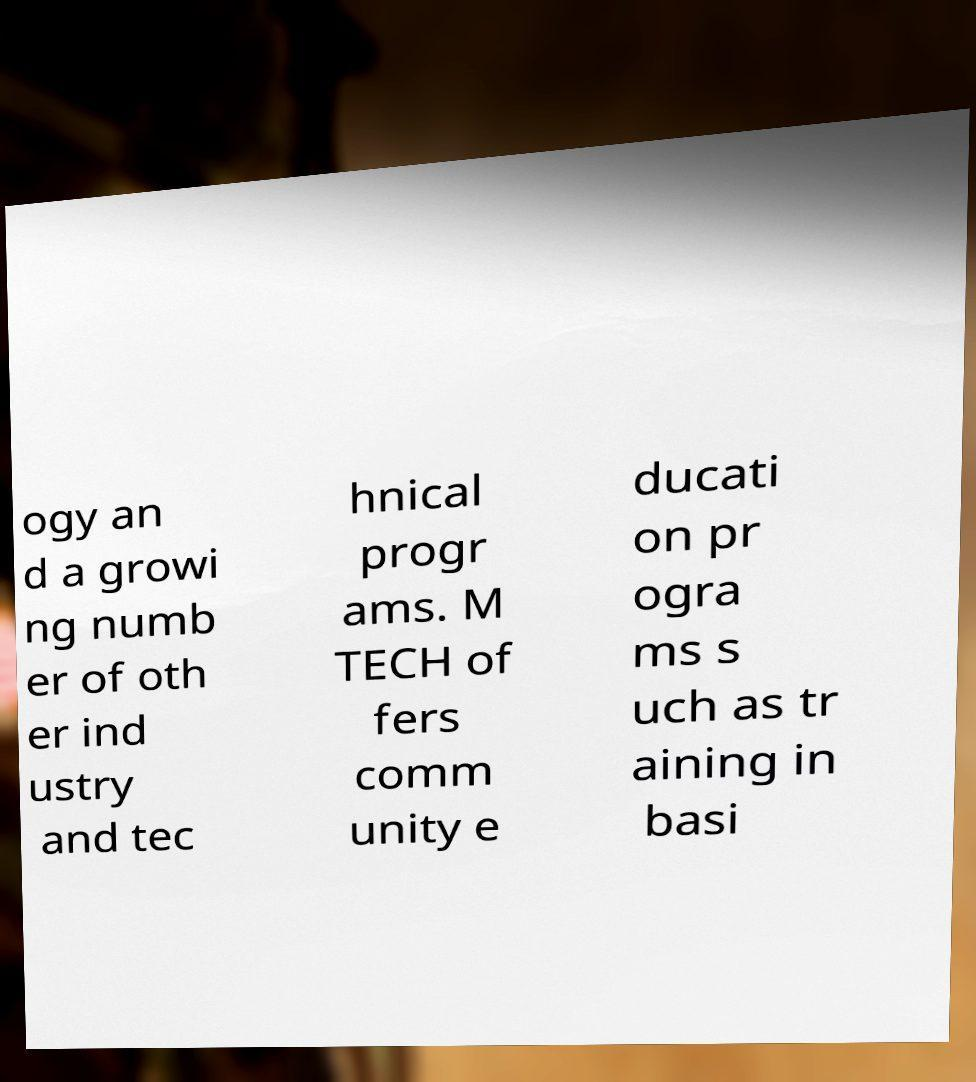Can you read and provide the text displayed in the image?This photo seems to have some interesting text. Can you extract and type it out for me? ogy an d a growi ng numb er of oth er ind ustry and tec hnical progr ams. M TECH of fers comm unity e ducati on pr ogra ms s uch as tr aining in basi 